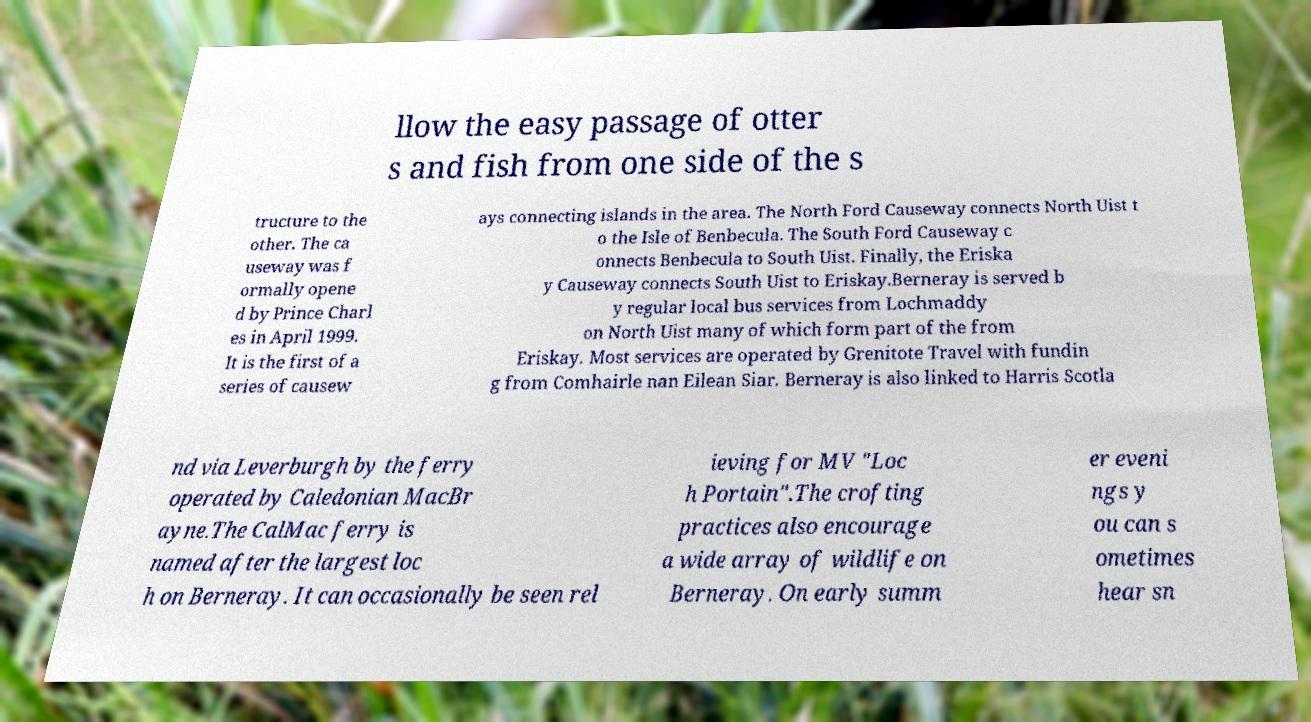What messages or text are displayed in this image? I need them in a readable, typed format. llow the easy passage of otter s and fish from one side of the s tructure to the other. The ca useway was f ormally opene d by Prince Charl es in April 1999. It is the first of a series of causew ays connecting islands in the area. The North Ford Causeway connects North Uist t o the Isle of Benbecula. The South Ford Causeway c onnects Benbecula to South Uist. Finally, the Eriska y Causeway connects South Uist to Eriskay.Berneray is served b y regular local bus services from Lochmaddy on North Uist many of which form part of the from Eriskay. Most services are operated by Grenitote Travel with fundin g from Comhairle nan Eilean Siar. Berneray is also linked to Harris Scotla nd via Leverburgh by the ferry operated by Caledonian MacBr ayne.The CalMac ferry is named after the largest loc h on Berneray. It can occasionally be seen rel ieving for MV "Loc h Portain".The crofting practices also encourage a wide array of wildlife on Berneray. On early summ er eveni ngs y ou can s ometimes hear sn 